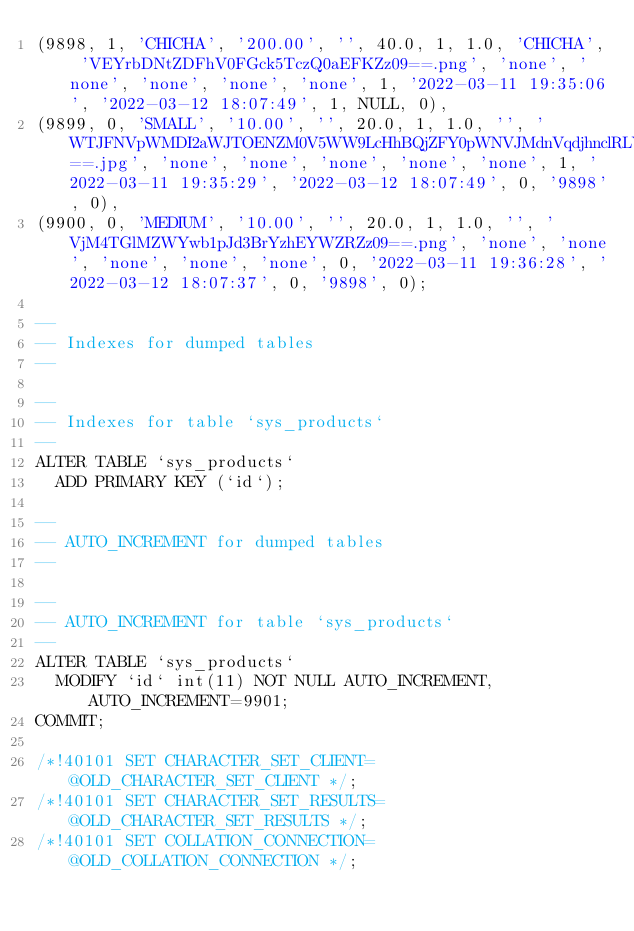<code> <loc_0><loc_0><loc_500><loc_500><_SQL_>(9898, 1, 'CHICHA', '200.00', '', 40.0, 1, 1.0, 'CHICHA', 'VEYrbDNtZDFhV0FGck5TczQ0aEFKZz09==.png', 'none', 'none', 'none', 'none', 'none', 1, '2022-03-11 19:35:06', '2022-03-12 18:07:49', 1, NULL, 0),
(9899, 0, 'SMALL', '10.00', '', 20.0, 1, 1.0, '', 'WTJFNVpWMDI2aWJTOENZM0V5WW9LcHhBQjZFY0pWNVJMdnVqdjhnclRLYz0==.jpg', 'none', 'none', 'none', 'none', 'none', 1, '2022-03-11 19:35:29', '2022-03-12 18:07:49', 0, '9898', 0),
(9900, 0, 'MEDIUM', '10.00', '', 20.0, 1, 1.0, '', 'VjM4TGlMZWYwb1pJd3BrYzhEYWZRZz09==.png', 'none', 'none', 'none', 'none', 'none', 0, '2022-03-11 19:36:28', '2022-03-12 18:07:37', 0, '9898', 0);

--
-- Indexes for dumped tables
--

--
-- Indexes for table `sys_products`
--
ALTER TABLE `sys_products`
  ADD PRIMARY KEY (`id`);

--
-- AUTO_INCREMENT for dumped tables
--

--
-- AUTO_INCREMENT for table `sys_products`
--
ALTER TABLE `sys_products`
  MODIFY `id` int(11) NOT NULL AUTO_INCREMENT, AUTO_INCREMENT=9901;
COMMIT;

/*!40101 SET CHARACTER_SET_CLIENT=@OLD_CHARACTER_SET_CLIENT */;
/*!40101 SET CHARACTER_SET_RESULTS=@OLD_CHARACTER_SET_RESULTS */;
/*!40101 SET COLLATION_CONNECTION=@OLD_COLLATION_CONNECTION */;
</code> 